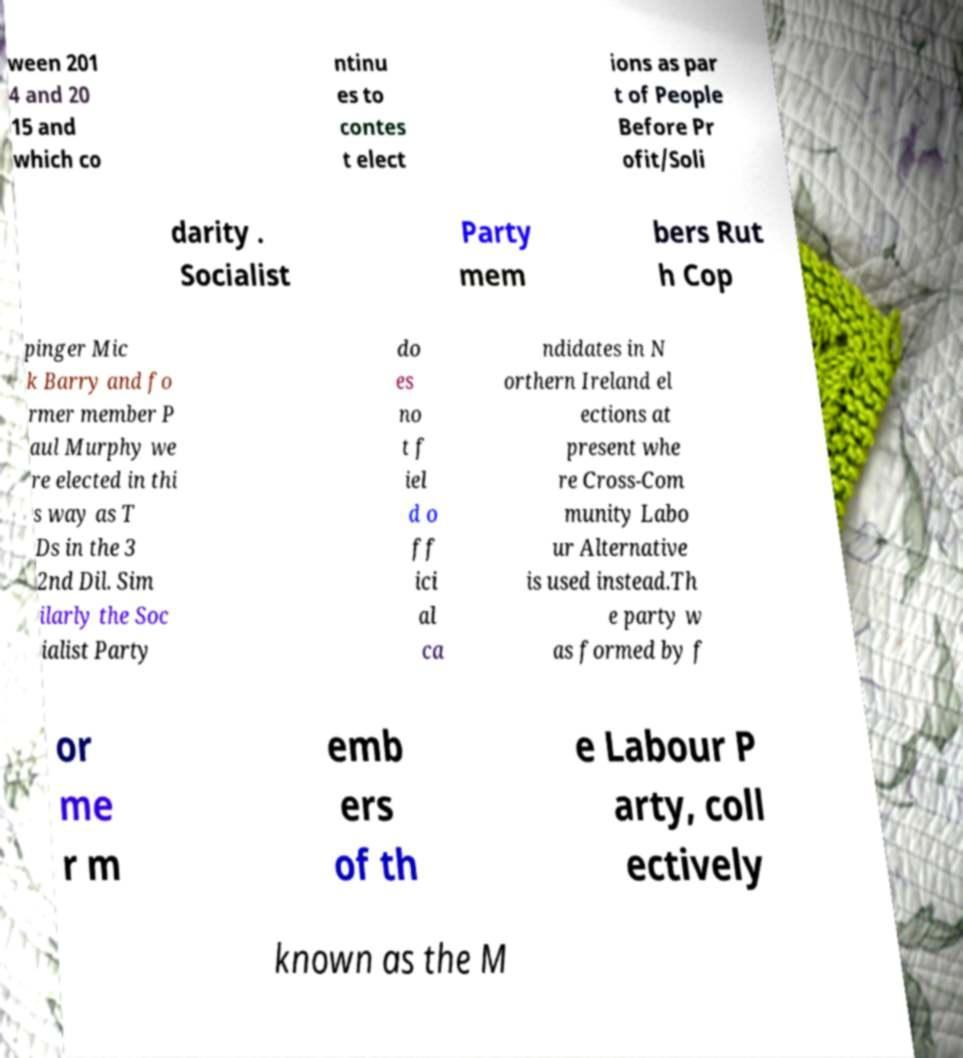For documentation purposes, I need the text within this image transcribed. Could you provide that? ween 201 4 and 20 15 and which co ntinu es to contes t elect ions as par t of People Before Pr ofit/Soli darity . Socialist Party mem bers Rut h Cop pinger Mic k Barry and fo rmer member P aul Murphy we re elected in thi s way as T Ds in the 3 2nd Dil. Sim ilarly the Soc ialist Party do es no t f iel d o ff ici al ca ndidates in N orthern Ireland el ections at present whe re Cross-Com munity Labo ur Alternative is used instead.Th e party w as formed by f or me r m emb ers of th e Labour P arty, coll ectively known as the M 